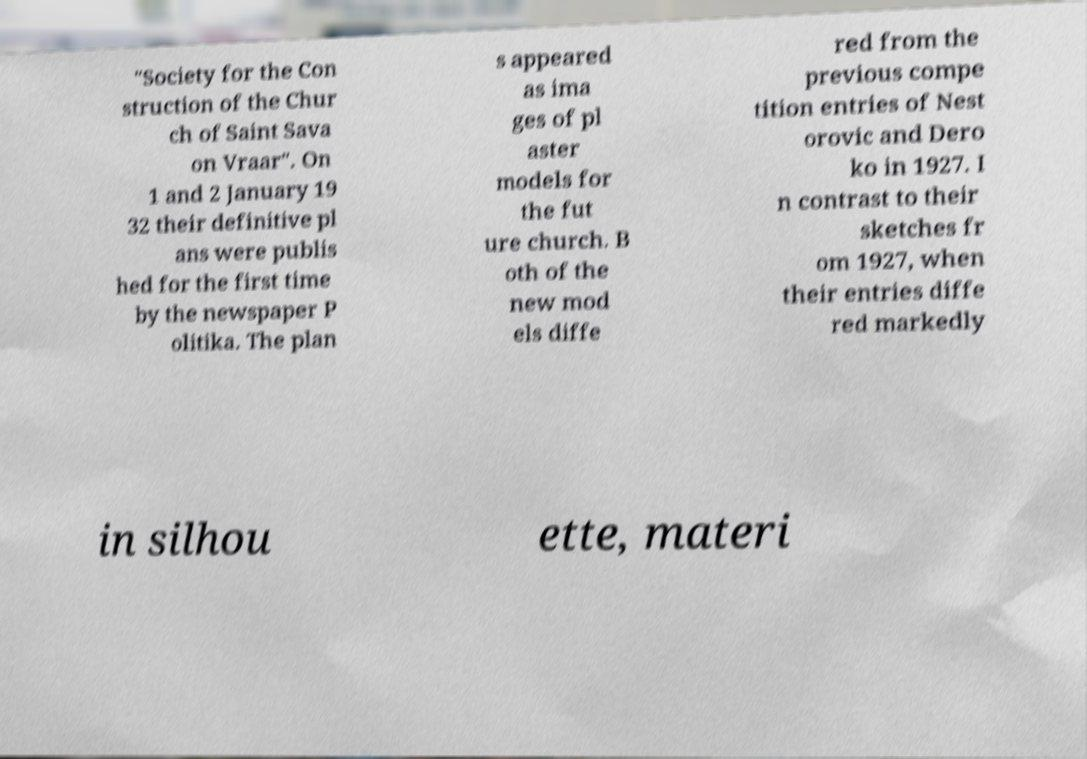Could you assist in decoding the text presented in this image and type it out clearly? "Society for the Con struction of the Chur ch of Saint Sava on Vraar". On 1 and 2 January 19 32 their definitive pl ans were publis hed for the first time by the newspaper P olitika. The plan s appeared as ima ges of pl aster models for the fut ure church. B oth of the new mod els diffe red from the previous compe tition entries of Nest orovic and Dero ko in 1927. I n contrast to their sketches fr om 1927, when their entries diffe red markedly in silhou ette, materi 